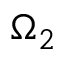<formula> <loc_0><loc_0><loc_500><loc_500>\Omega _ { 2 }</formula> 